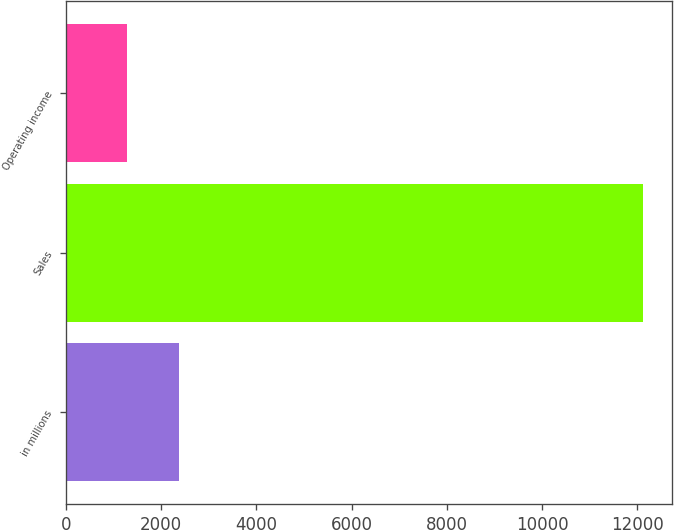Convert chart to OTSL. <chart><loc_0><loc_0><loc_500><loc_500><bar_chart><fcel>in millions<fcel>Sales<fcel>Operating income<nl><fcel>2373.2<fcel>12131<fcel>1289<nl></chart> 